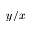<formula> <loc_0><loc_0><loc_500><loc_500>y / x</formula> 